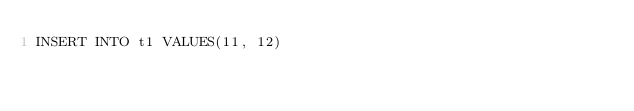Convert code to text. <code><loc_0><loc_0><loc_500><loc_500><_SQL_>INSERT INTO t1 VALUES(11, 12)</code> 